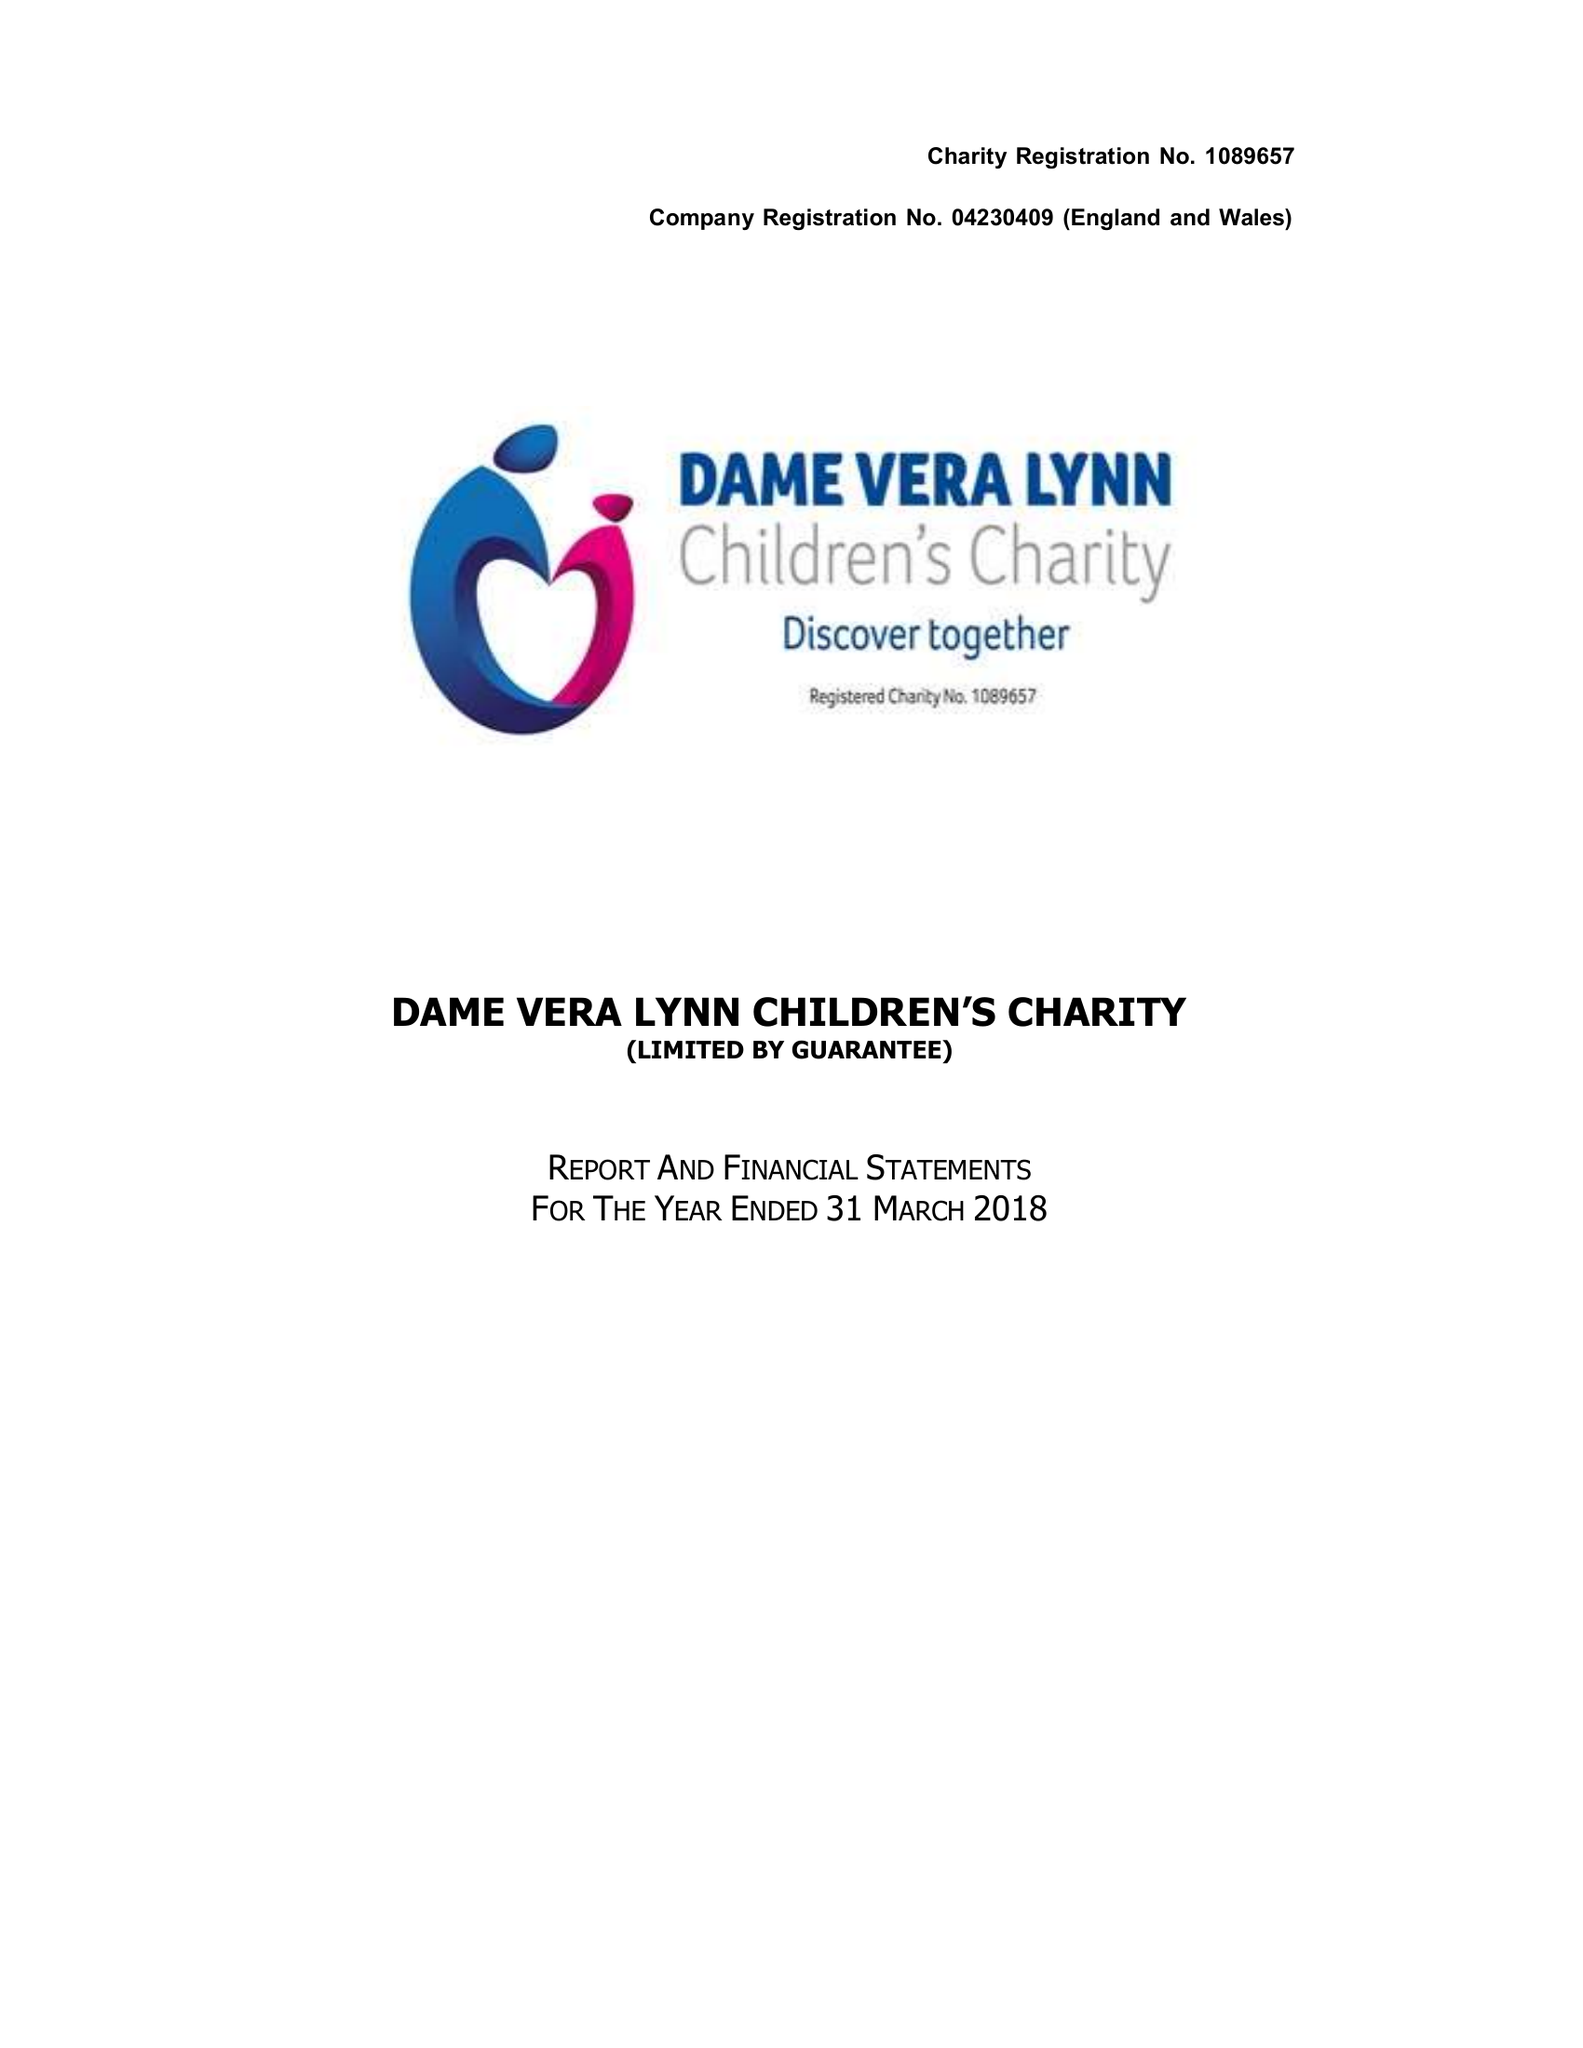What is the value for the charity_number?
Answer the question using a single word or phrase. 1089657 